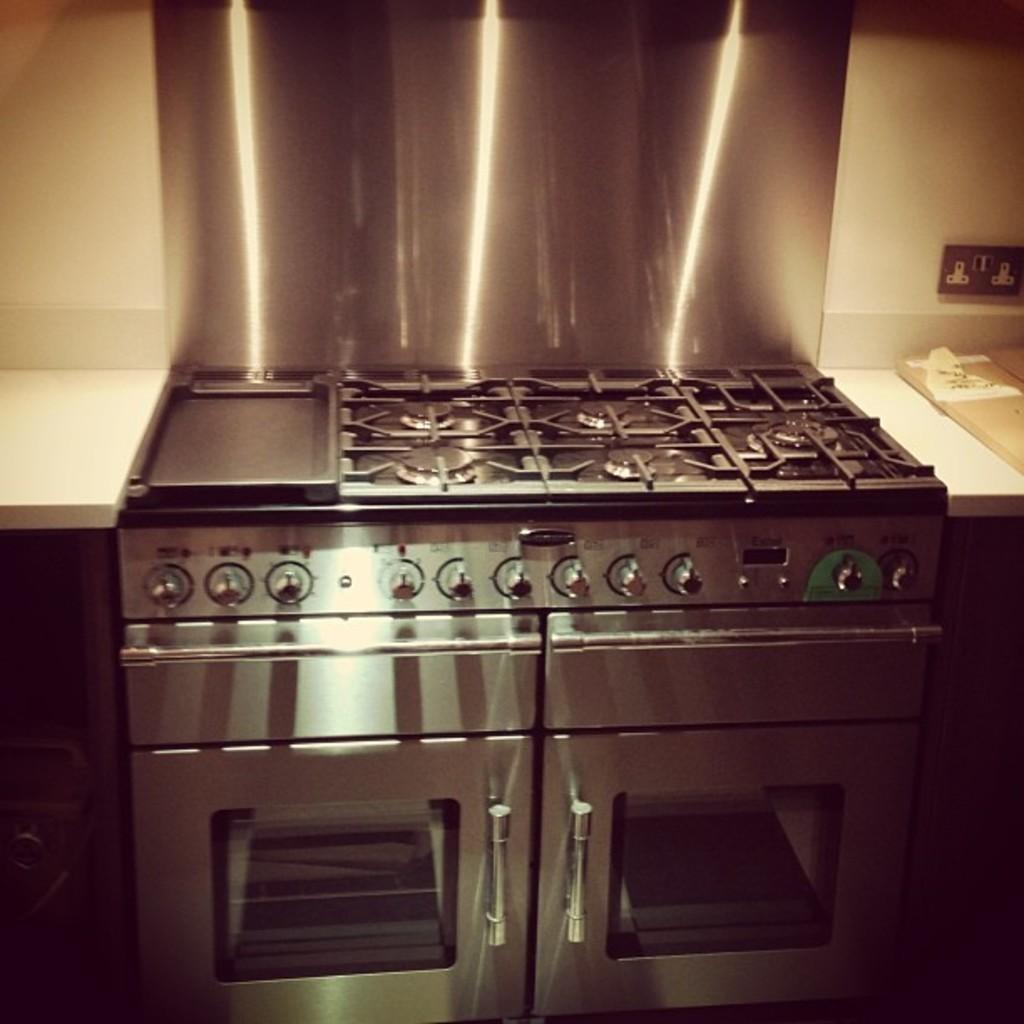What type of appliance is visible in the image? There is a stove in the image. Where is the stove located? The stove is on a kitchen countertop. What can be seen in the background of the image? There is a wall in the background of the image. What type of boot is hanging on the wall in the image? There is no boot present in the image; it only features a stove on a kitchen countertop and a wall in the background. 